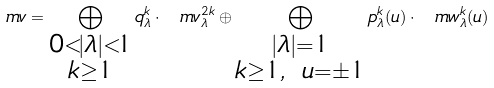<formula> <loc_0><loc_0><loc_500><loc_500>\ m v = \bigoplus _ { \substack { 0 < | \lambda | < 1 \\ k \geq 1 } } q ^ { k } _ { \lambda } \cdot \ m v ^ { 2 k } _ { \lambda } \oplus \bigoplus _ { \substack { | \lambda | = 1 \\ k \geq 1 , \ u = \pm 1 } } p ^ { k } _ { \lambda } ( u ) \cdot \ m w ^ { k } _ { \lambda } ( u )</formula> 